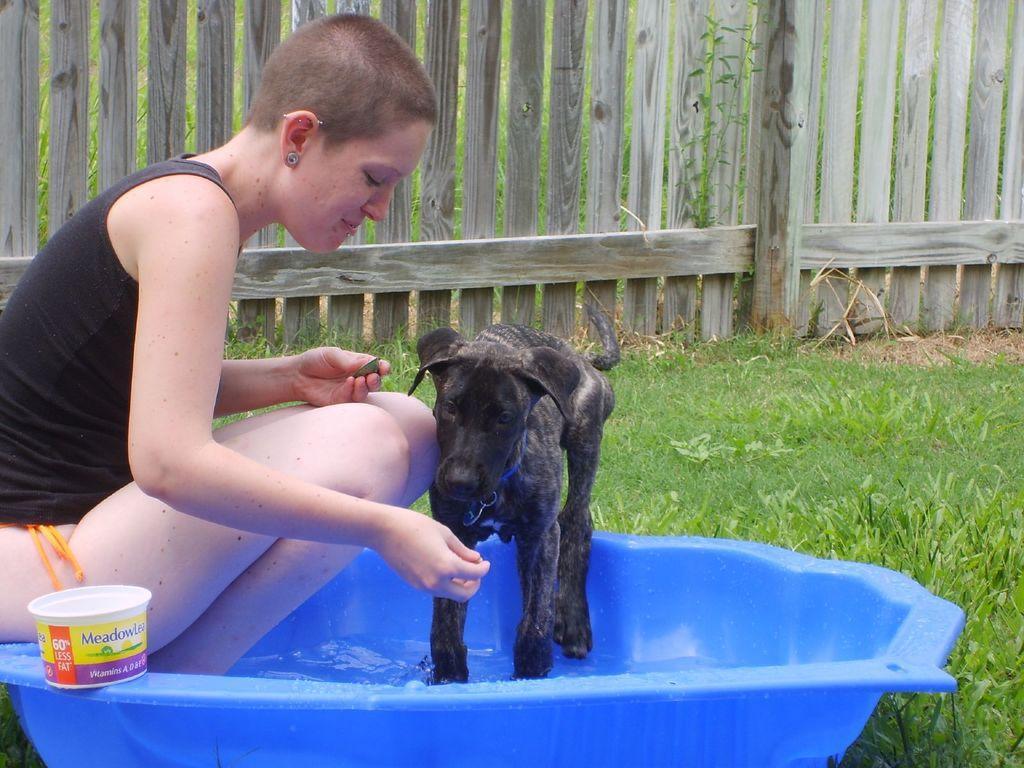Can you describe this image briefly? In this image we can see a tub with water. There is a lady sitting on the tub. Also there is a box. And we can see a dog in the tub. On the ground there is grass. In the background there is a wooden fencing. 